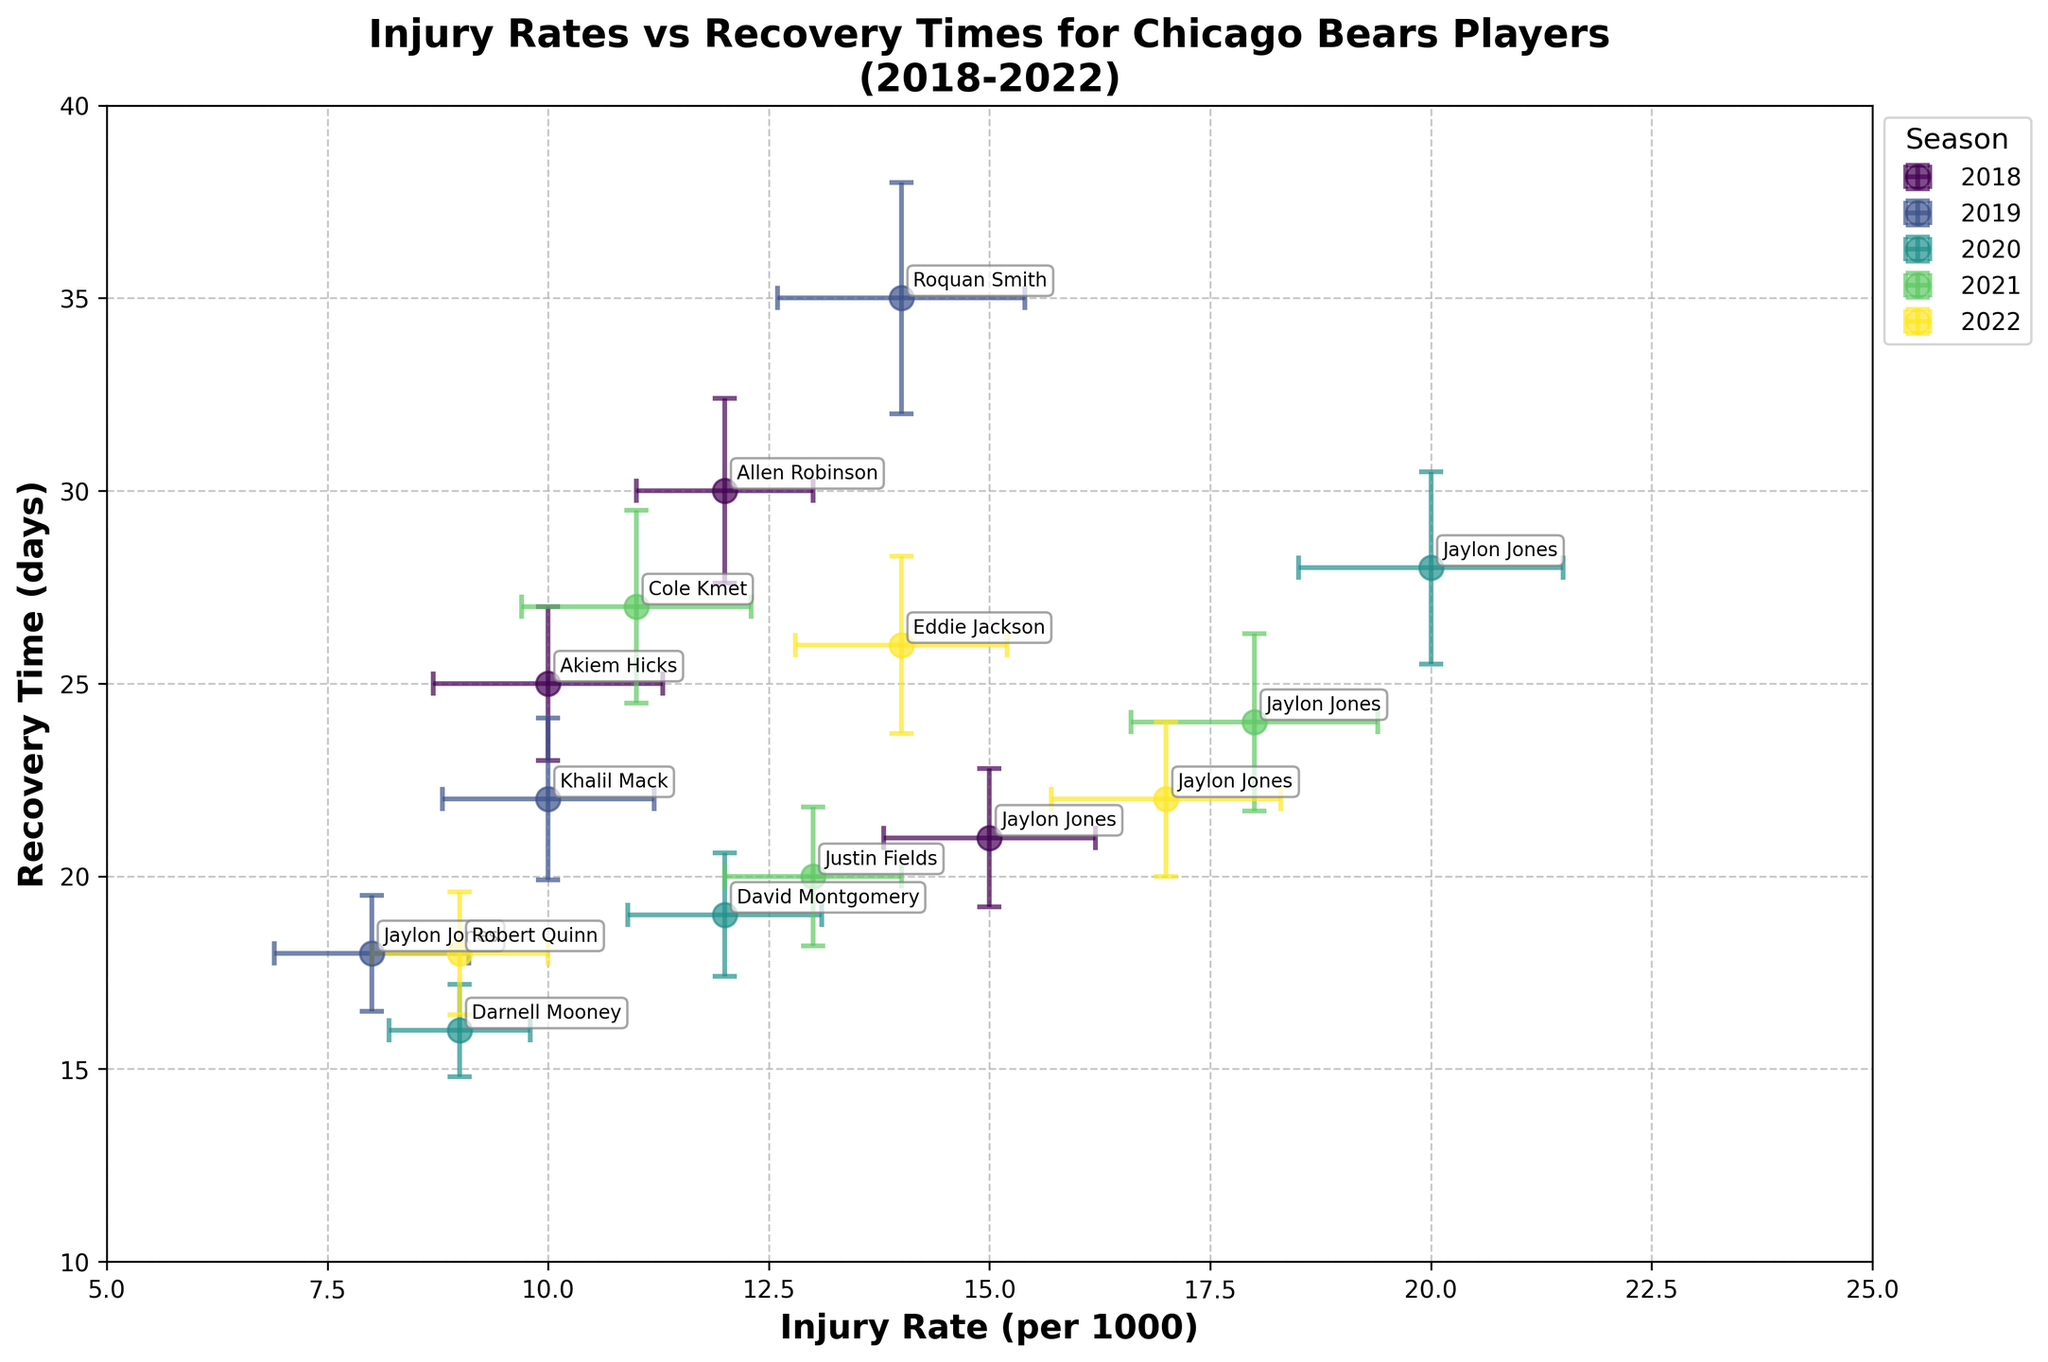Which player had the highest recovery time in 2018? By looking at the data points for 2018 and noting the y-axis values for recovery time, we identify that Allen Robinson had the highest recovery time.
Answer: Allen Robinson Which season had the most data points plotted? Count the number of data points annotated for each season. The 2020 season has three players annotated, which is the highest.
Answer: 2020 What was the average injury rate for Jaylon Jones over the five seasons? Jaylon Jones's injury rates over five seasons are 15, 8, 20, 18, and 17. Summing these gives 78. Dividing by 5, the average injury rate is 15.6.
Answer: 15.6 Which player had the lowest injury rate in 2020? By checking the data points for 2020 and comparing their positions on the x-axis, Darnell Mooney had the lowest injury rate.
Answer: Darnell Mooney Which player had the highest recovery time in 2021, and what was it? By checking the data points for 2021 and looking at the y-axis values, Cole Kmet had the highest recovery time with 27 days.
Answer: Cole Kmet, 27 days In which season did Jaylon Jones have the highest injury rate? By comparing the injury rates represented by Jaylon Jones across all seasons, the highest rate is seen in 2020 with an injury rate of 20.
Answer: 2020 What is the range of recovery times for players in the 2019 season? The recovery times for 2019 are 18, 22, and 35 days. The range is found by subtracting the smallest value from the largest, 35 - 18 = 17 days.
Answer: 17 days Which season has the data point with the smallest standard error for recovery time? By examining the error bars and standard error values, the smallest standard error for recovery time is 1.2, associated with Darnell Mooney in 2020.
Answer: 2020 For the 2022 season, what was the average recovery time for the players? Summing the recovery times for 2022 (22, 26, and 18 days) gives 66. Dividing by the number of players (3), the average is 66 / 3 = 22 days.
Answer: 22 days Which player exhibited the largest standard error of injury rate, and in which season? By looking at the data and error bars for injury rates, the largest error (1.5) is shown by Jaylon Jones in 2020.
Answer: Jaylon Jones, 2020 